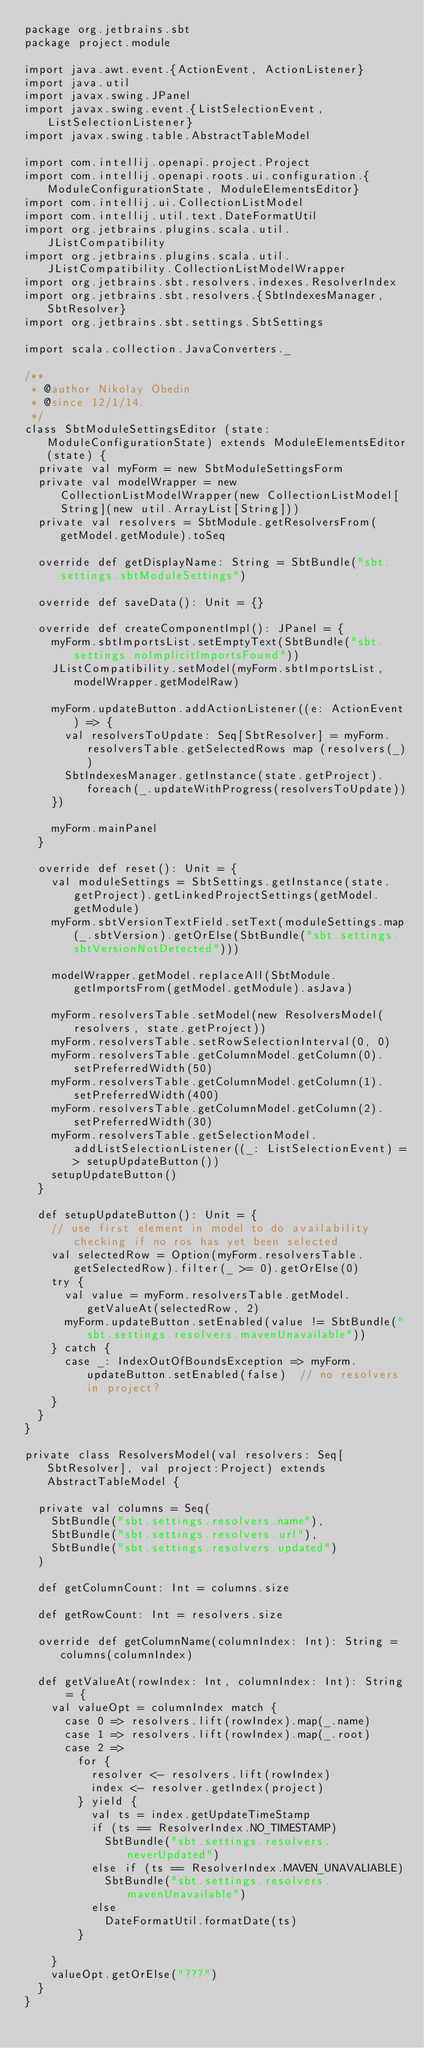Convert code to text. <code><loc_0><loc_0><loc_500><loc_500><_Scala_>package org.jetbrains.sbt
package project.module

import java.awt.event.{ActionEvent, ActionListener}
import java.util
import javax.swing.JPanel
import javax.swing.event.{ListSelectionEvent, ListSelectionListener}
import javax.swing.table.AbstractTableModel

import com.intellij.openapi.project.Project
import com.intellij.openapi.roots.ui.configuration.{ModuleConfigurationState, ModuleElementsEditor}
import com.intellij.ui.CollectionListModel
import com.intellij.util.text.DateFormatUtil
import org.jetbrains.plugins.scala.util.JListCompatibility
import org.jetbrains.plugins.scala.util.JListCompatibility.CollectionListModelWrapper
import org.jetbrains.sbt.resolvers.indexes.ResolverIndex
import org.jetbrains.sbt.resolvers.{SbtIndexesManager, SbtResolver}
import org.jetbrains.sbt.settings.SbtSettings

import scala.collection.JavaConverters._

/**
 * @author Nikolay Obedin
 * @since 12/1/14.
 */
class SbtModuleSettingsEditor (state: ModuleConfigurationState) extends ModuleElementsEditor(state) {
  private val myForm = new SbtModuleSettingsForm
  private val modelWrapper = new CollectionListModelWrapper(new CollectionListModel[String](new util.ArrayList[String]))
  private val resolvers = SbtModule.getResolversFrom(getModel.getModule).toSeq

  override def getDisplayName: String = SbtBundle("sbt.settings.sbtModuleSettings")

  override def saveData(): Unit = {}

  override def createComponentImpl(): JPanel = {
    myForm.sbtImportsList.setEmptyText(SbtBundle("sbt.settings.noImplicitImportsFound"))
    JListCompatibility.setModel(myForm.sbtImportsList, modelWrapper.getModelRaw)

    myForm.updateButton.addActionListener((e: ActionEvent) => {
      val resolversToUpdate: Seq[SbtResolver] = myForm.resolversTable.getSelectedRows map (resolvers(_))
      SbtIndexesManager.getInstance(state.getProject).foreach(_.updateWithProgress(resolversToUpdate))
    })

    myForm.mainPanel
  }

  override def reset(): Unit = {
    val moduleSettings = SbtSettings.getInstance(state.getProject).getLinkedProjectSettings(getModel.getModule)
    myForm.sbtVersionTextField.setText(moduleSettings.map(_.sbtVersion).getOrElse(SbtBundle("sbt.settings.sbtVersionNotDetected")))

    modelWrapper.getModel.replaceAll(SbtModule.getImportsFrom(getModel.getModule).asJava)

    myForm.resolversTable.setModel(new ResolversModel(resolvers, state.getProject))
    myForm.resolversTable.setRowSelectionInterval(0, 0)
    myForm.resolversTable.getColumnModel.getColumn(0).setPreferredWidth(50)
    myForm.resolversTable.getColumnModel.getColumn(1).setPreferredWidth(400)
    myForm.resolversTable.getColumnModel.getColumn(2).setPreferredWidth(30)
    myForm.resolversTable.getSelectionModel.addListSelectionListener((_: ListSelectionEvent) => setupUpdateButton())
    setupUpdateButton()
  }

  def setupUpdateButton(): Unit = {
    // use first element in model to do availability checking if no ros has yet been selected
    val selectedRow = Option(myForm.resolversTable.getSelectedRow).filter(_ >= 0).getOrElse(0)
    try {
      val value = myForm.resolversTable.getModel.getValueAt(selectedRow, 2)
      myForm.updateButton.setEnabled(value != SbtBundle("sbt.settings.resolvers.mavenUnavailable"))
    } catch {
      case _: IndexOutOfBoundsException => myForm.updateButton.setEnabled(false)  // no resolvers in project?
    }
  }
}

private class ResolversModel(val resolvers: Seq[SbtResolver], val project:Project) extends AbstractTableModel {

  private val columns = Seq(
    SbtBundle("sbt.settings.resolvers.name"),
    SbtBundle("sbt.settings.resolvers.url"),
    SbtBundle("sbt.settings.resolvers.updated")
  )

  def getColumnCount: Int = columns.size

  def getRowCount: Int = resolvers.size

  override def getColumnName(columnIndex: Int): String = columns(columnIndex)

  def getValueAt(rowIndex: Int, columnIndex: Int): String = {
    val valueOpt = columnIndex match {
      case 0 => resolvers.lift(rowIndex).map(_.name)
      case 1 => resolvers.lift(rowIndex).map(_.root)
      case 2 =>
        for {
          resolver <- resolvers.lift(rowIndex)
          index <- resolver.getIndex(project)
        } yield {
          val ts = index.getUpdateTimeStamp
          if (ts == ResolverIndex.NO_TIMESTAMP)
            SbtBundle("sbt.settings.resolvers.neverUpdated")
          else if (ts == ResolverIndex.MAVEN_UNAVALIABLE)
            SbtBundle("sbt.settings.resolvers.mavenUnavailable")
          else
            DateFormatUtil.formatDate(ts)
        }

    }
    valueOpt.getOrElse("???")
  }
}
</code> 